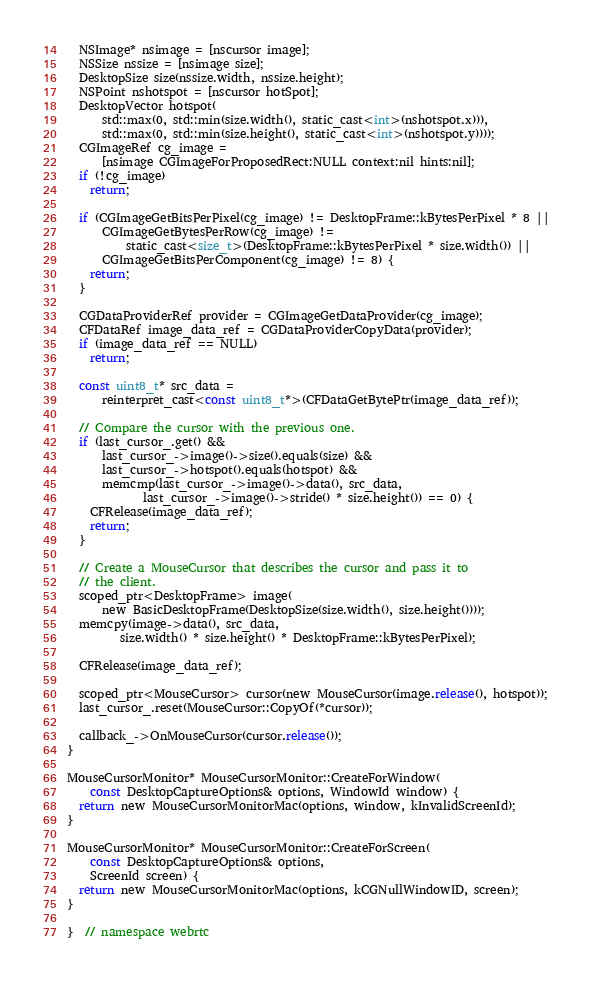Convert code to text. <code><loc_0><loc_0><loc_500><loc_500><_ObjectiveC_>
  NSImage* nsimage = [nscursor image];
  NSSize nssize = [nsimage size];
  DesktopSize size(nssize.width, nssize.height);
  NSPoint nshotspot = [nscursor hotSpot];
  DesktopVector hotspot(
      std::max(0, std::min(size.width(), static_cast<int>(nshotspot.x))),
      std::max(0, std::min(size.height(), static_cast<int>(nshotspot.y))));
  CGImageRef cg_image =
      [nsimage CGImageForProposedRect:NULL context:nil hints:nil];
  if (!cg_image)
    return;

  if (CGImageGetBitsPerPixel(cg_image) != DesktopFrame::kBytesPerPixel * 8 ||
      CGImageGetBytesPerRow(cg_image) !=
          static_cast<size_t>(DesktopFrame::kBytesPerPixel * size.width()) ||
      CGImageGetBitsPerComponent(cg_image) != 8) {
    return;
  }

  CGDataProviderRef provider = CGImageGetDataProvider(cg_image);
  CFDataRef image_data_ref = CGDataProviderCopyData(provider);
  if (image_data_ref == NULL)
    return;

  const uint8_t* src_data =
      reinterpret_cast<const uint8_t*>(CFDataGetBytePtr(image_data_ref));

  // Compare the cursor with the previous one.
  if (last_cursor_.get() &&
      last_cursor_->image()->size().equals(size) &&
      last_cursor_->hotspot().equals(hotspot) &&
      memcmp(last_cursor_->image()->data(), src_data,
             last_cursor_->image()->stride() * size.height()) == 0) {
    CFRelease(image_data_ref);
    return;
  }

  // Create a MouseCursor that describes the cursor and pass it to
  // the client.
  scoped_ptr<DesktopFrame> image(
      new BasicDesktopFrame(DesktopSize(size.width(), size.height())));
  memcpy(image->data(), src_data,
         size.width() * size.height() * DesktopFrame::kBytesPerPixel);

  CFRelease(image_data_ref);

  scoped_ptr<MouseCursor> cursor(new MouseCursor(image.release(), hotspot));
  last_cursor_.reset(MouseCursor::CopyOf(*cursor));

  callback_->OnMouseCursor(cursor.release());
}

MouseCursorMonitor* MouseCursorMonitor::CreateForWindow(
    const DesktopCaptureOptions& options, WindowId window) {
  return new MouseCursorMonitorMac(options, window, kInvalidScreenId);
}

MouseCursorMonitor* MouseCursorMonitor::CreateForScreen(
    const DesktopCaptureOptions& options,
    ScreenId screen) {
  return new MouseCursorMonitorMac(options, kCGNullWindowID, screen);
}

}  // namespace webrtc
</code> 